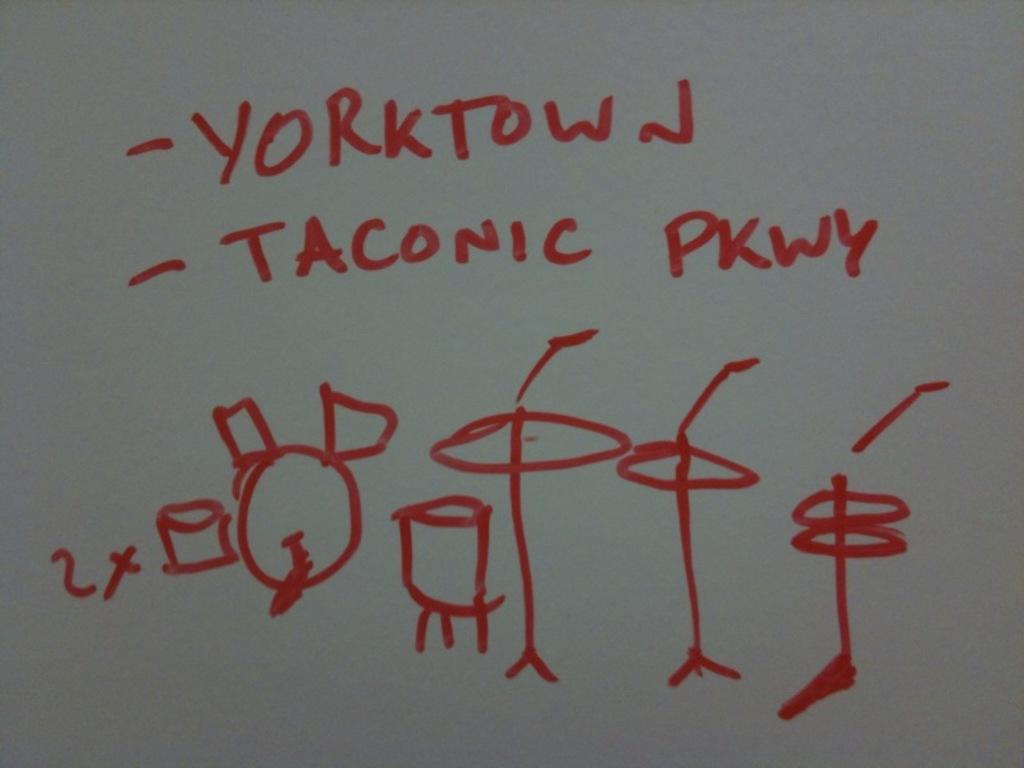<image>
Provide a brief description of the given image. A drawing with a drum set has Yorktown written at the top. 